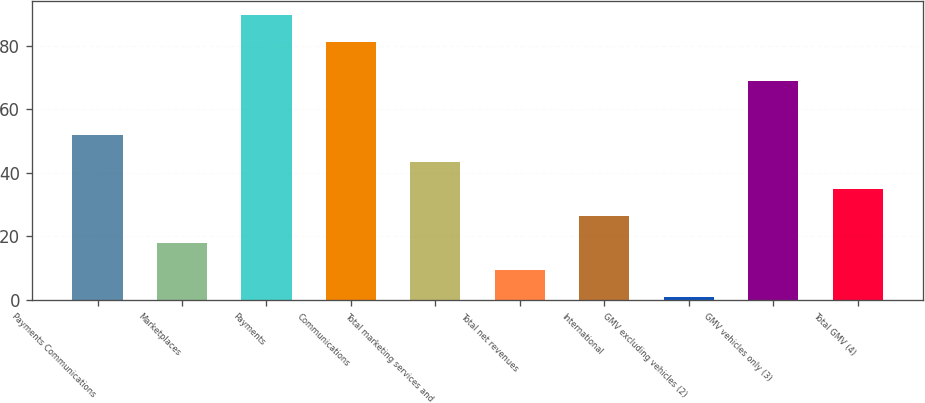<chart> <loc_0><loc_0><loc_500><loc_500><bar_chart><fcel>Payments Communications<fcel>Marketplaces<fcel>Payments<fcel>Communications<fcel>Total marketing services and<fcel>Total net revenues<fcel>International<fcel>GMV excluding vehicles (2)<fcel>GMV vehicles only (3)<fcel>Total GMV (4)<nl><fcel>52<fcel>18<fcel>89.5<fcel>81<fcel>43.5<fcel>9.5<fcel>26.5<fcel>1<fcel>69<fcel>35<nl></chart> 